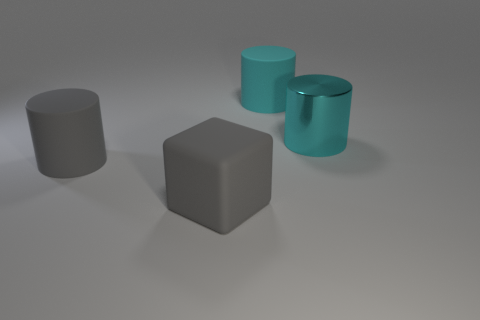What is the color of the cube that is the same material as the gray cylinder?
Your answer should be very brief. Gray. What number of gray cylinders have the same material as the gray block?
Offer a terse response. 1. What number of big gray things are there?
Offer a very short reply. 2. There is a object that is behind the metal cylinder; does it have the same color as the object that is to the right of the large cyan rubber thing?
Your answer should be very brief. Yes. There is a big cyan matte object; what number of big cylinders are on the right side of it?
Offer a very short reply. 1. Is there a gray matte object that has the same shape as the large shiny thing?
Give a very brief answer. Yes. Is the thing in front of the big gray cylinder made of the same material as the large gray thing that is behind the cube?
Offer a very short reply. Yes. There is a matte cylinder that is left of the rubber object behind the gray rubber object left of the big block; what size is it?
Offer a terse response. Large. There is another cyan cylinder that is the same size as the cyan rubber cylinder; what material is it?
Your answer should be compact. Metal. Is there a gray thing that has the same size as the cyan metal cylinder?
Your answer should be compact. Yes. 